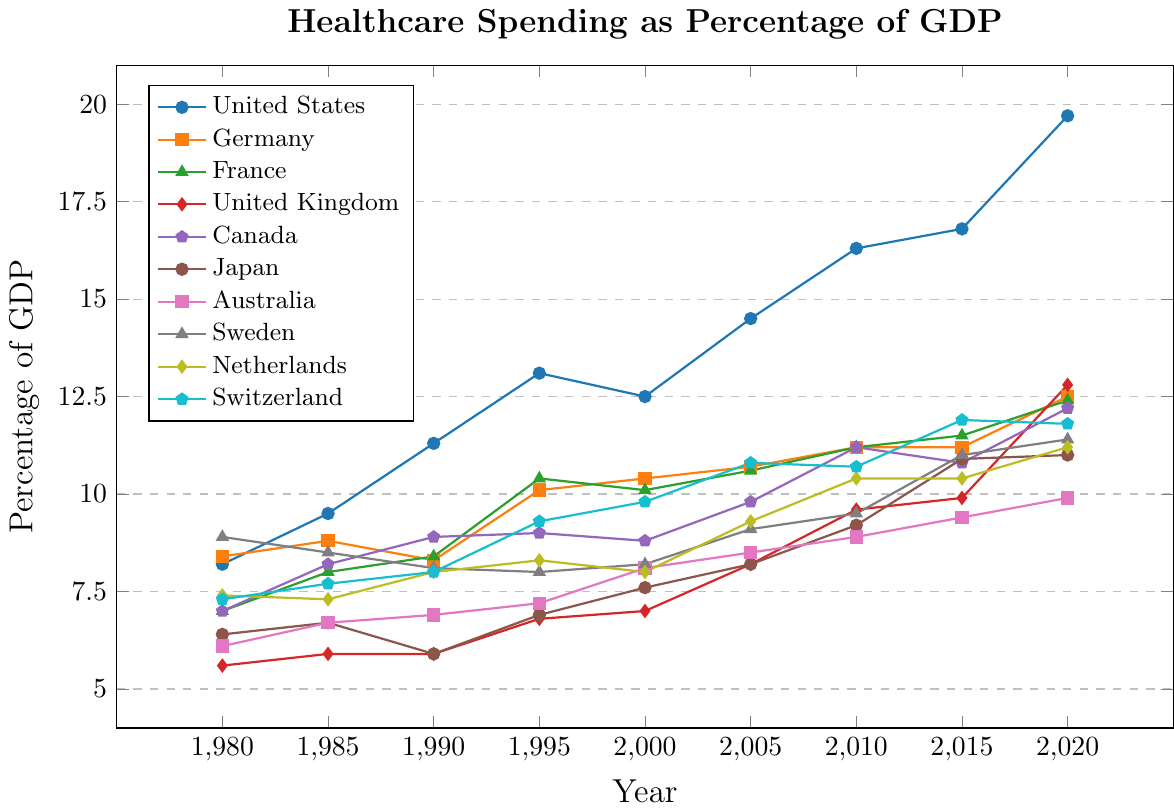What is the percentage increase in the United States healthcare spending from 1980 to 2020? To find the percentage increase, subtract the 1980 value (8.2) from the 2020 value (19.7), which equals 11.5. Then divide by the 1980 value (8.2) and multiply by 100 to get the percentage increase: \(\frac{11.5}{8.2} \times 100 \approx 140.24\).
Answer: 140.24% Which country had the highest healthcare spending as a percentage of GDP in 2020? By looking at the data for 2020, the United States has the highest value at 19.7%. This is higher than all other countries listed.
Answer: United States How did France's healthcare spending change from 1995 to 2005? Was it an increase or decrease? In 1995, France's spending was 10.4%, and in 2005 it was 10.6%. Subtracting the 1995 value from the 2005 value (10.6 - 10.4) shows an increase of 0.2%.
Answer: Increase Which two countries had nearly equal healthcare spending in 2010, and what were their values? In 2010, both Canada and France had healthcare spending values of 11.2%, indicating they had nearly equal spending as a percentage of GDP in that year.
Answer: Canada and France, 11.2% Compare the healthcare spending percentages of the United Kingdom and Germany in 2000. Which was higher and by how much? The United Kingdom had 7.0% and Germany had 10.4% in 2000. Subtract the United Kingdom’s value from Germany’s value (10.4 - 7.0) to find the difference: 3.4%.
Answer: Germany by 3.4% What was the average healthcare spending percentage of Australia from 1980 to 2020? To find the average, sum the data points for Australia from 1980 to 2020: (6.1 + 6.7 + 6.9 + 7.2 + 8.1 + 8.5 + 8.9 + 9.4 + 9.9) = 71.7. Divide this sum by the number of data points (9): 71.7 / 9 ≈ 7.97.
Answer: 7.97% Did any country's healthcare spending decrease during any five-year period? If so, which country and period? Sweden's healthcare spending decreased from 8.9% in 1980 to 8.5% in 1985. This is the only country and period where a decrease is observed.
Answer: Sweden from 1980 to 1985 What trend do you observe in Japan's healthcare spending from 1980 to 2020? The value starts at 6.4% in 1980, drops to 5.9% in 1990, and then continuously rises to 11.0% in 2020. This shows an overall upward trend with an initial dip.
Answer: Upward trend with initial dip Which countries had similar healthcare spending trajectories from 1990 to 2020? Describe their spending patterns. The United Kingdom and France had similar trajectories; both countries showed a consistent increase in healthcare spending over these years, with values converging towards the end. For instance, in 2020, France was at 12.4% and UK at 12.8%.
Answer: United Kingdom and France Out of the listed countries, which had the smallest overall increase in healthcare spending from 1980 to 2020? By subtracting the 1980 values from the 2020 values for each country, Japan’s increase from 6.4% to 11.0% (4.6%) is the smallest overall increase.
Answer: Japan 